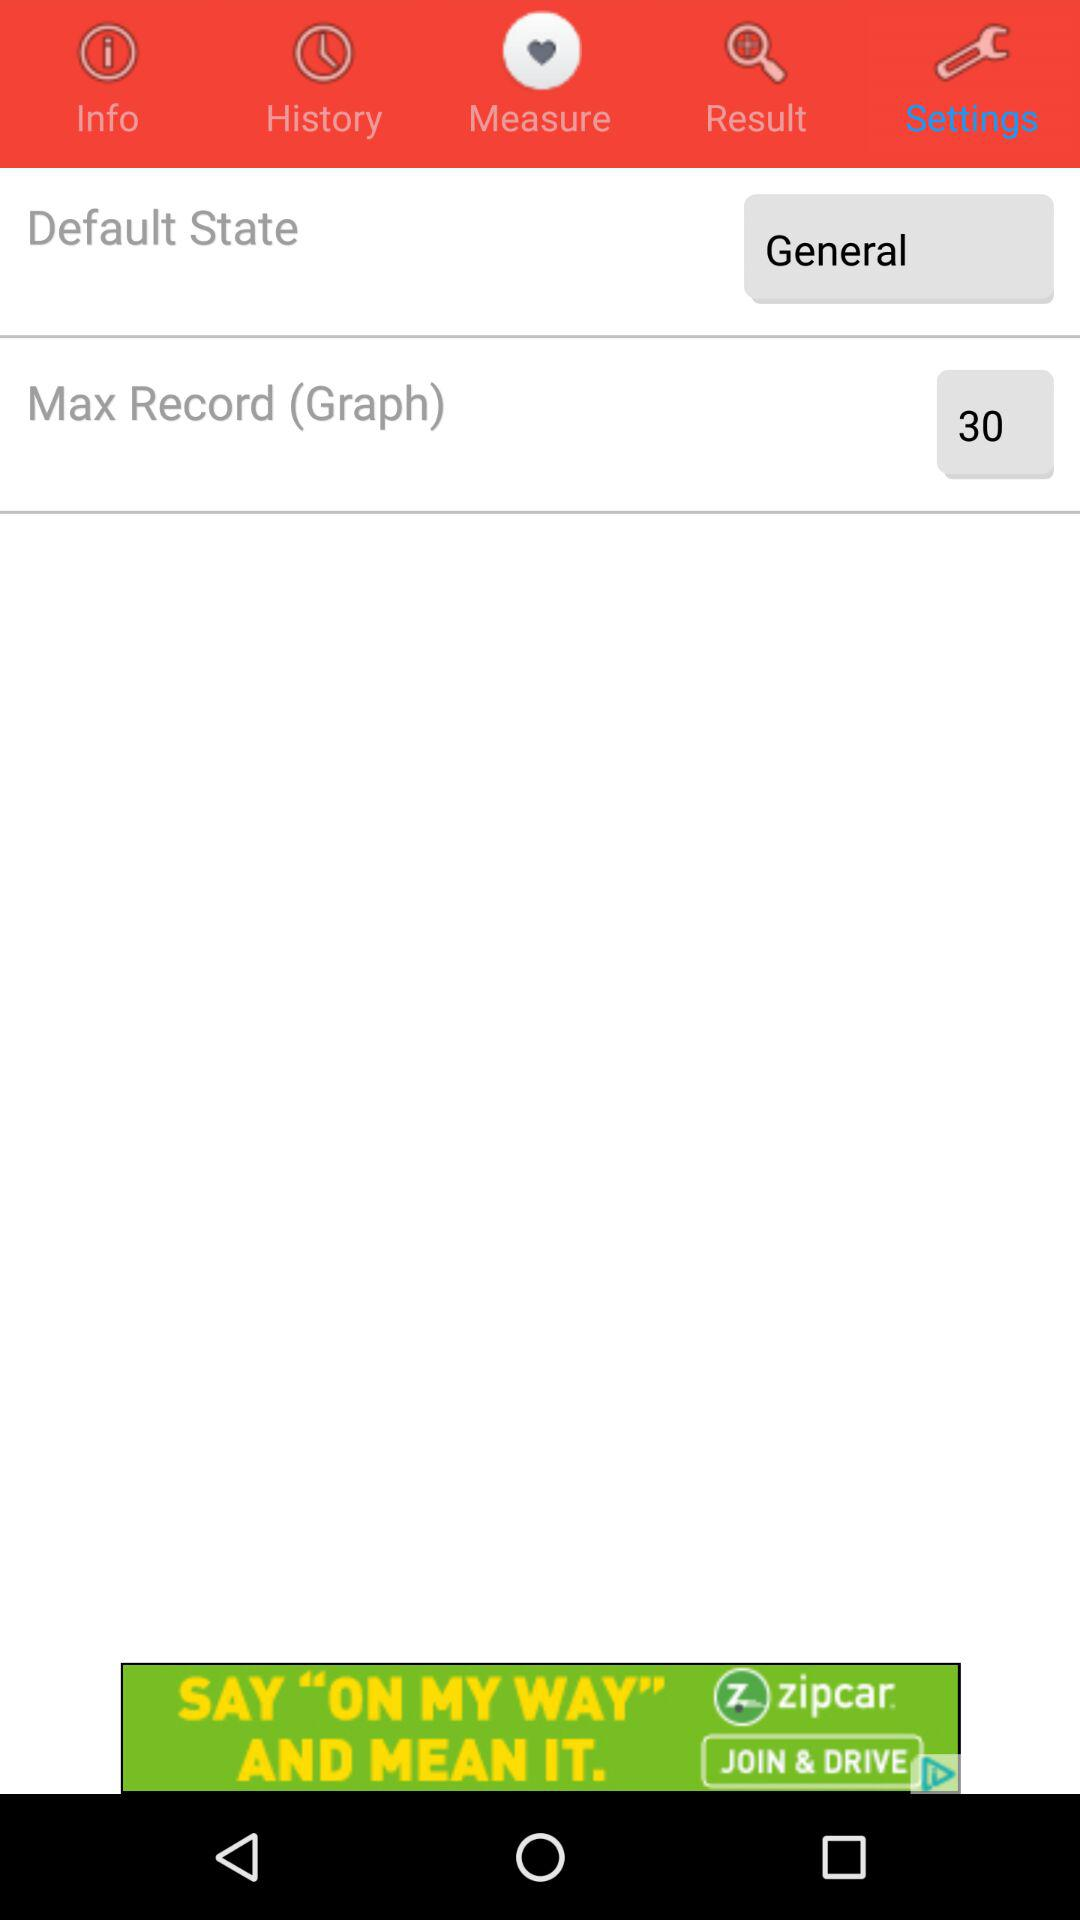What is the status of "Default State"? The status is "General". 